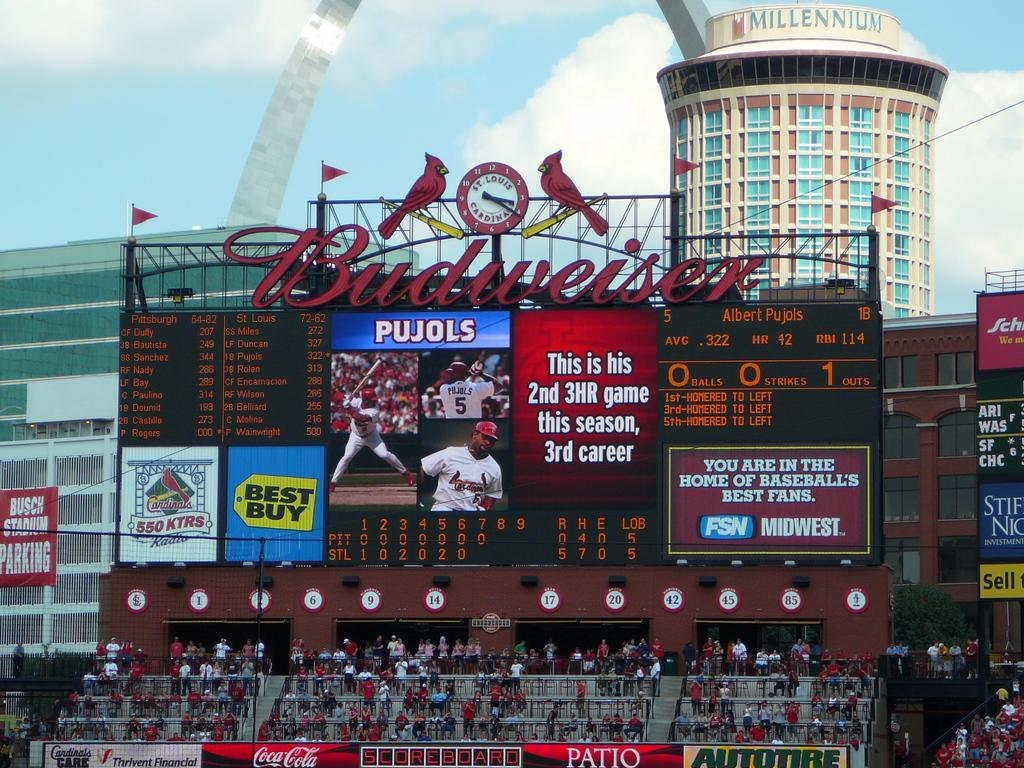<image>
Create a compact narrative representing the image presented. Albert Pujols has hit three home runs in this baseball game. 